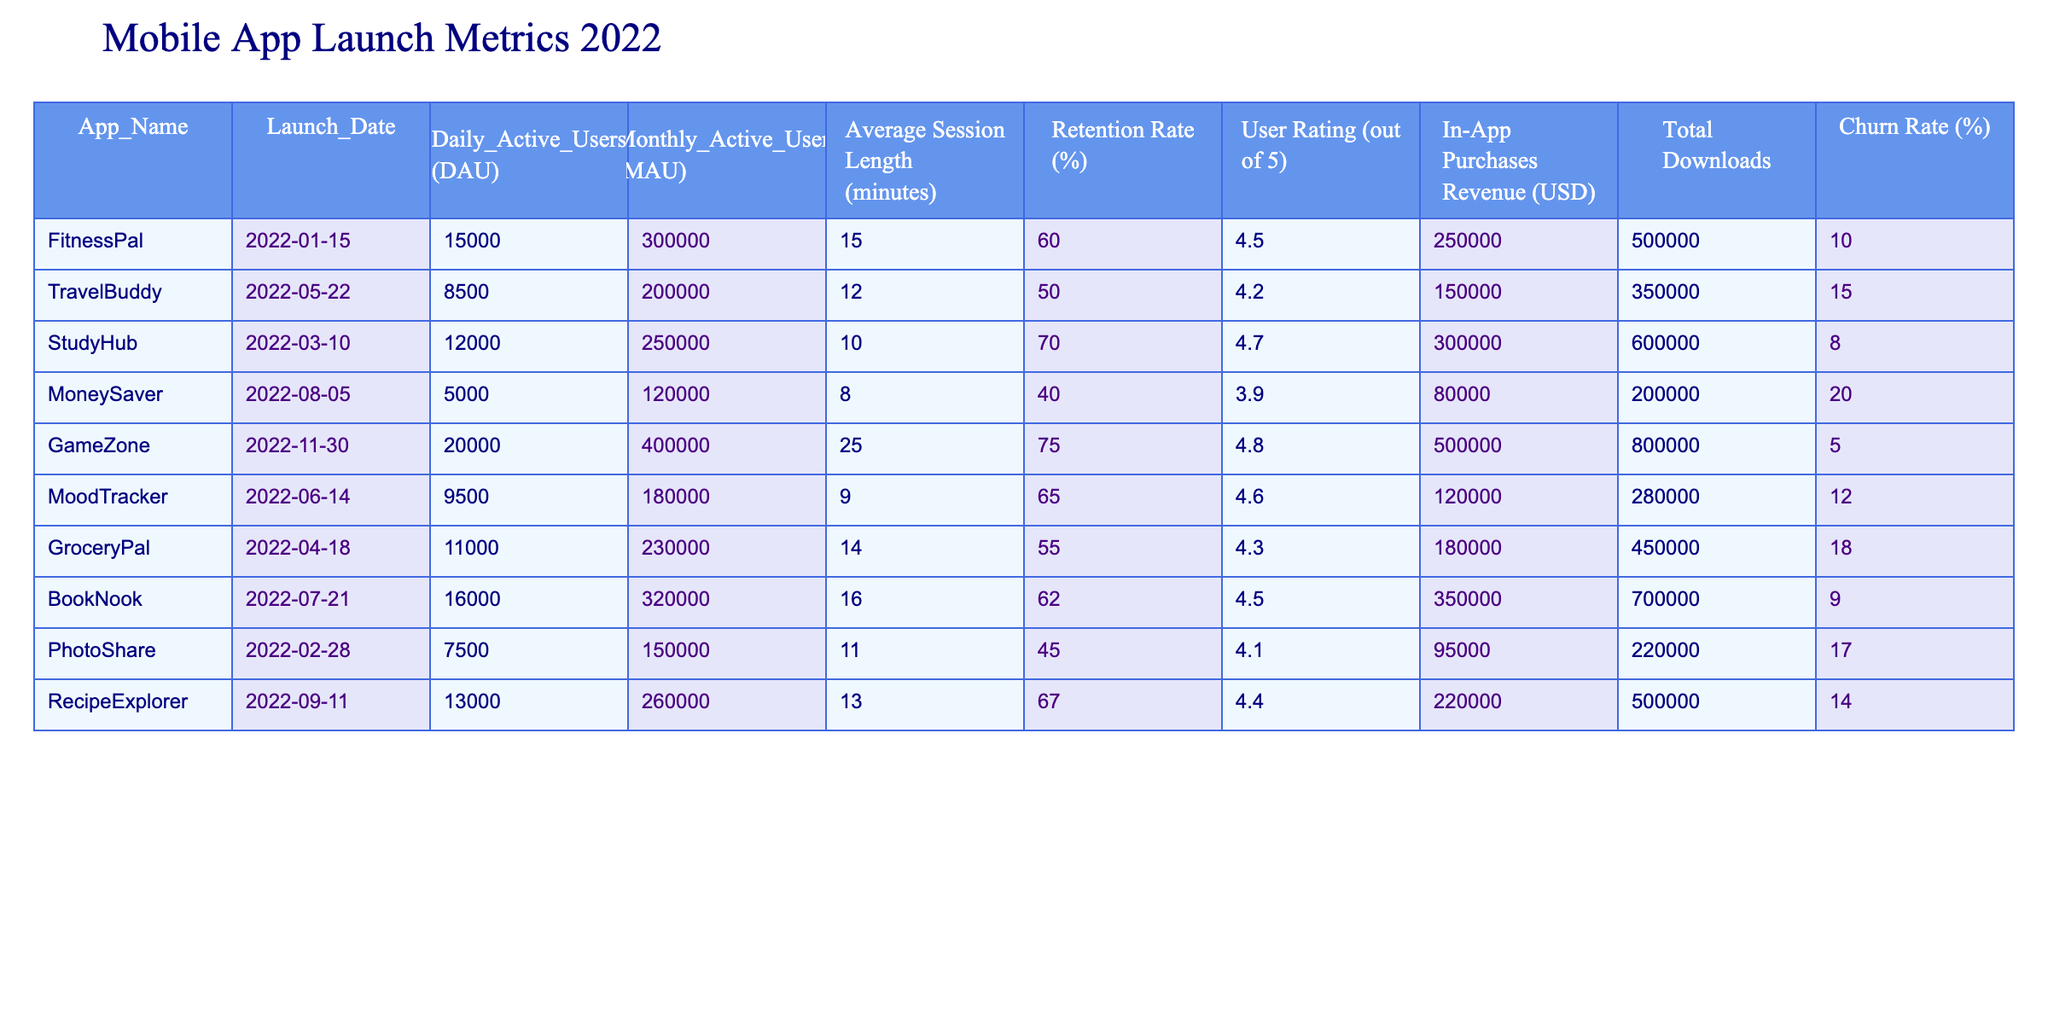What is the average Daily Active Users (DAU) across all apps? To find the average DAU, we need to add the DAUs from each app and then divide by the total number of apps. The DAUs are: 15000, 8500, 12000, 5000, 20000, 9500, 11000, 16000, 7500, and 13000. The total sum is 15000 + 8500 + 12000 + 5000 + 20000 + 9500 + 11000 + 16000 + 7500 + 13000 = 115500. There are 10 apps, so the average DAU is 115500 / 10 = 11550.
Answer: 11550 Which app has the highest Retention Rate? By looking for the maximum value in the Retention Rate column, we can identify the app with the highest percentage. The rates are: 60, 50, 70, 40, 75, 65, 55, 62, 45, and 67. The highest value is 75%, which belongs to GameZone.
Answer: GameZone Is the User Rating for RecipeExplorer greater than 4.5? We can check the User Rating for RecipeExplorer, which is 4.4. Since 4.4 is not greater than 4.5, the statement is false.
Answer: No How many total downloads were there for apps with a Churn Rate lower than 10%? We first identify the apps with a Churn Rate lower than 10%, which are FitnessPal (10%), StudyHub (8%), and GameZone (5%). However, since none of these are lower than 10%, there are no downloads to sum. The total downloads for these apps are 500000, 600000, and 800000 respectively, totaling 500000 + 600000 + 800000 = 1900000.
Answer: 1900000 Which app earns the most revenue from In-App Purchases? To determine which app has the most revenue, we look for the maximum value in the In-App Purchases Revenue column. The revenues are: 250000, 150000, 300000, 80000, 500000, 120000, 180000, 350000, 95000, and 220000. The highest revenue, 500000, belongs to GameZone.
Answer: GameZone 